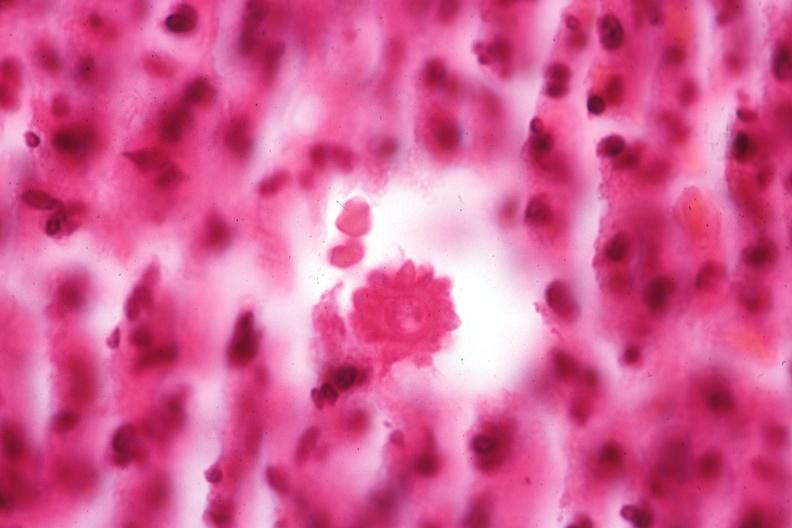what does this image show?
Answer the question using a single word or phrase. Oil immersion organism very well shown 